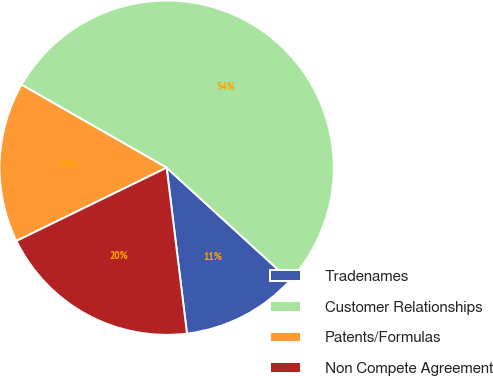Convert chart to OTSL. <chart><loc_0><loc_0><loc_500><loc_500><pie_chart><fcel>Tradenames<fcel>Customer Relationships<fcel>Patents/Formulas<fcel>Non Compete Agreement<nl><fcel>11.27%<fcel>53.52%<fcel>15.49%<fcel>19.72%<nl></chart> 